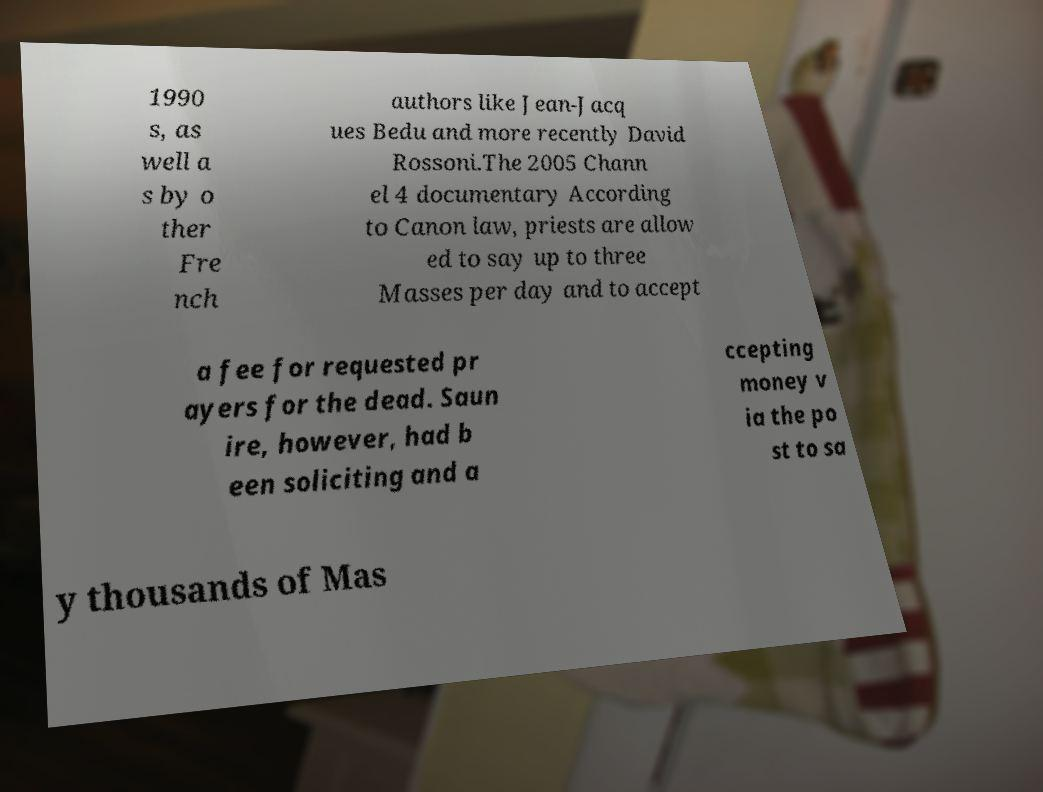Can you accurately transcribe the text from the provided image for me? 1990 s, as well a s by o ther Fre nch authors like Jean-Jacq ues Bedu and more recently David Rossoni.The 2005 Chann el 4 documentary According to Canon law, priests are allow ed to say up to three Masses per day and to accept a fee for requested pr ayers for the dead. Saun ire, however, had b een soliciting and a ccepting money v ia the po st to sa y thousands of Mas 